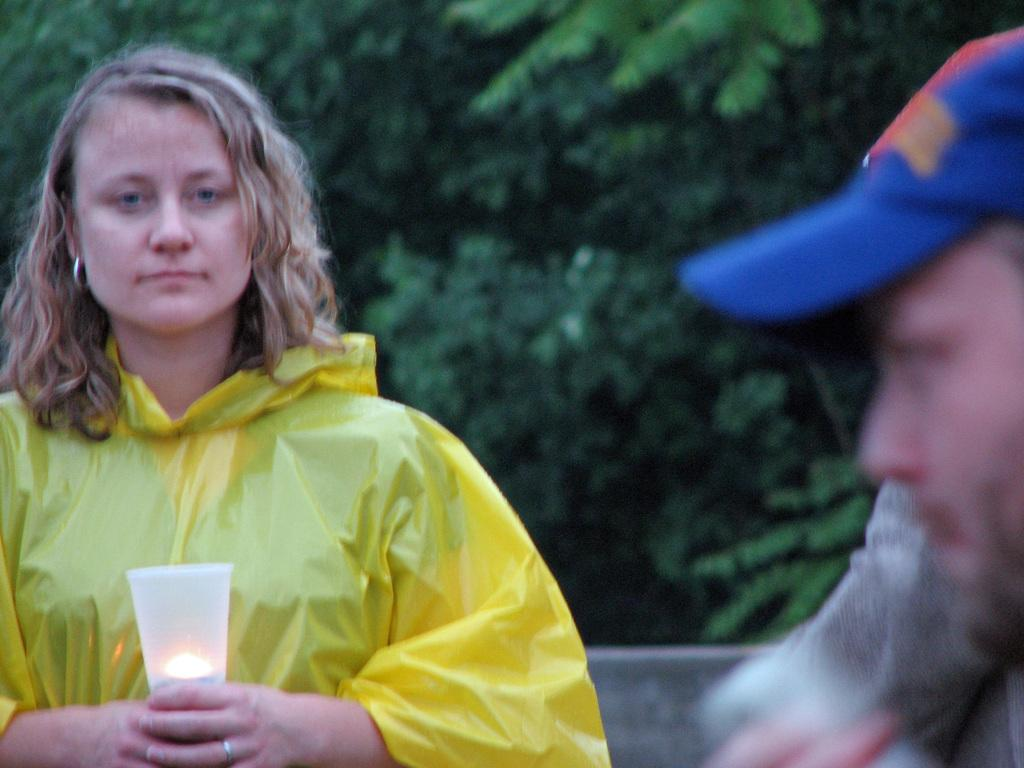Who is the main subject in the image? There is a lady in the image. What is the lady wearing? The lady is wearing a yellow coat. What is the lady holding in her hand? The lady is holding a light in her hand. Can you describe the person on the right side of the image? There is a person on the right side of the image, but no specific details are provided. What can be seen in the background of the image? There are trees in the background of the image, and the background is blurred. What direction is the lady facing in the image? The direction the lady is facing cannot be determined from the image. How does the lady react to the north in the image? There is no indication of the lady reacting to any specific direction, including north, in the image. 